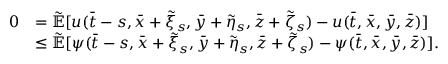<formula> <loc_0><loc_0><loc_500><loc_500>\begin{array} { r l } { 0 } & { = \mathbb { \tilde { E } } [ u ( \bar { t } - s , \bar { x } + \tilde { \xi } _ { s } , \bar { y } + \tilde { \eta } _ { s } , \bar { z } + \tilde { \zeta } _ { s } ) - u ( \bar { t } , \bar { x } , \bar { y } , \bar { z } ) ] } \\ & { \leq \mathbb { \tilde { E } } [ \psi ( \bar { t } - s , \bar { x } + \tilde { \xi } _ { s } , \bar { y } + \tilde { \eta } _ { s } , \bar { z } + \tilde { \zeta } _ { s } ) - \psi ( \bar { t } , \bar { x } , \bar { y } , \bar { z } ) ] . } \end{array}</formula> 